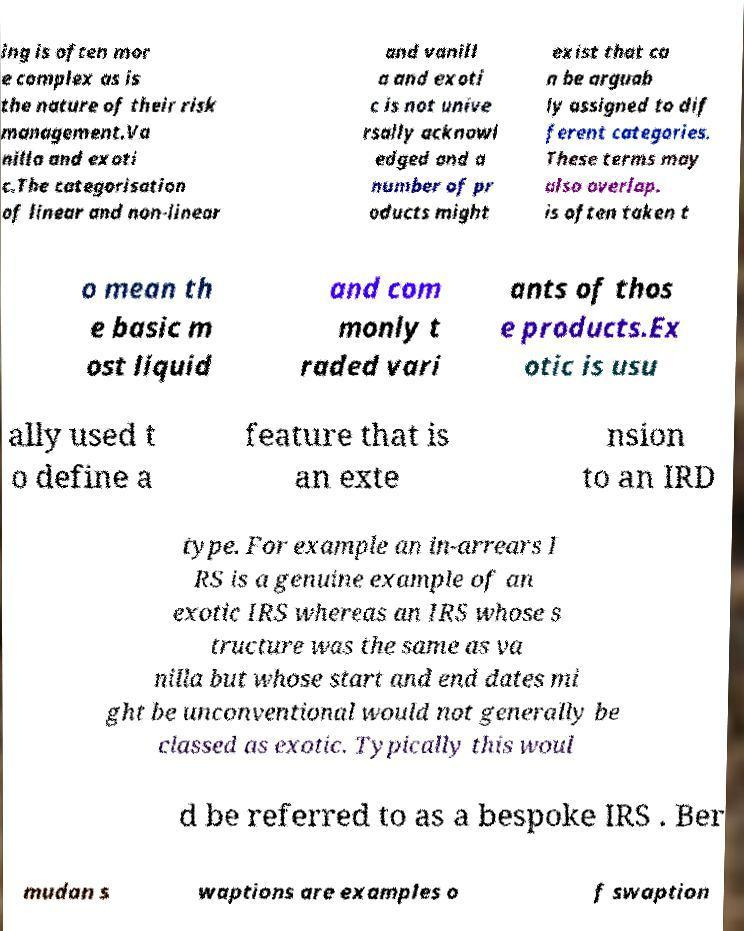I need the written content from this picture converted into text. Can you do that? ing is often mor e complex as is the nature of their risk management.Va nilla and exoti c.The categorisation of linear and non-linear and vanill a and exoti c is not unive rsally acknowl edged and a number of pr oducts might exist that ca n be arguab ly assigned to dif ferent categories. These terms may also overlap. is often taken t o mean th e basic m ost liquid and com monly t raded vari ants of thos e products.Ex otic is usu ally used t o define a feature that is an exte nsion to an IRD type. For example an in-arrears I RS is a genuine example of an exotic IRS whereas an IRS whose s tructure was the same as va nilla but whose start and end dates mi ght be unconventional would not generally be classed as exotic. Typically this woul d be referred to as a bespoke IRS . Ber mudan s waptions are examples o f swaption 